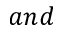<formula> <loc_0><loc_0><loc_500><loc_500>a n d</formula> 